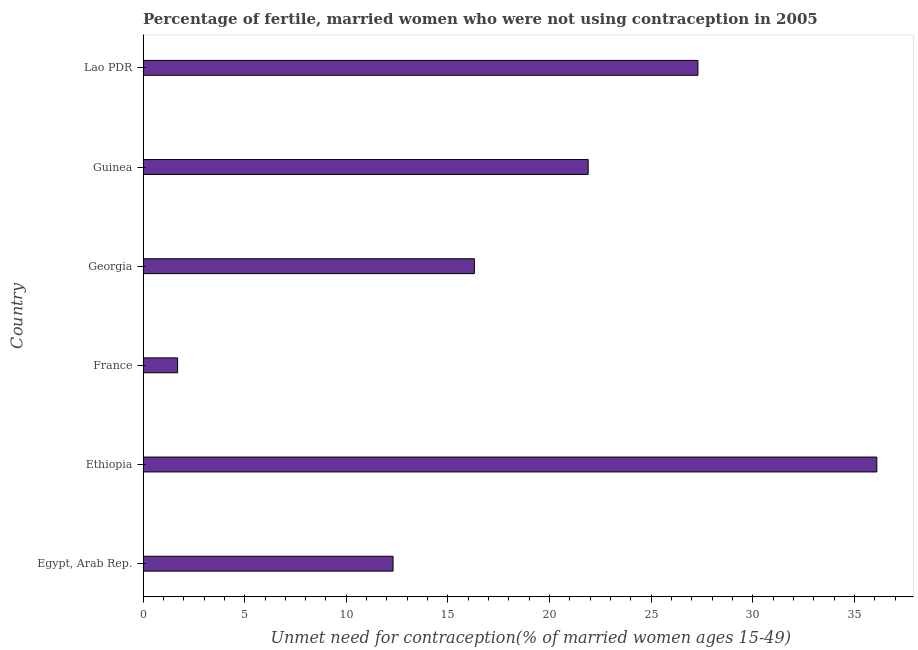Does the graph contain grids?
Your response must be concise. No. What is the title of the graph?
Keep it short and to the point. Percentage of fertile, married women who were not using contraception in 2005. What is the label or title of the X-axis?
Offer a terse response.  Unmet need for contraception(% of married women ages 15-49). Across all countries, what is the maximum number of married women who are not using contraception?
Provide a succinct answer. 36.1. Across all countries, what is the minimum number of married women who are not using contraception?
Offer a very short reply. 1.7. In which country was the number of married women who are not using contraception maximum?
Your response must be concise. Ethiopia. What is the sum of the number of married women who are not using contraception?
Keep it short and to the point. 115.6. What is the difference between the number of married women who are not using contraception in France and Lao PDR?
Keep it short and to the point. -25.6. What is the average number of married women who are not using contraception per country?
Keep it short and to the point. 19.27. What is the median number of married women who are not using contraception?
Your answer should be very brief. 19.1. What is the ratio of the number of married women who are not using contraception in Egypt, Arab Rep. to that in France?
Offer a very short reply. 7.24. What is the difference between the highest and the second highest number of married women who are not using contraception?
Ensure brevity in your answer.  8.8. What is the difference between the highest and the lowest number of married women who are not using contraception?
Offer a terse response. 34.4. How many bars are there?
Ensure brevity in your answer.  6. Are all the bars in the graph horizontal?
Offer a terse response. Yes. How many countries are there in the graph?
Your answer should be compact. 6. What is the  Unmet need for contraception(% of married women ages 15-49) in Egypt, Arab Rep.?
Your response must be concise. 12.3. What is the  Unmet need for contraception(% of married women ages 15-49) in Ethiopia?
Give a very brief answer. 36.1. What is the  Unmet need for contraception(% of married women ages 15-49) of Guinea?
Ensure brevity in your answer.  21.9. What is the  Unmet need for contraception(% of married women ages 15-49) in Lao PDR?
Your answer should be compact. 27.3. What is the difference between the  Unmet need for contraception(% of married women ages 15-49) in Egypt, Arab Rep. and Ethiopia?
Offer a terse response. -23.8. What is the difference between the  Unmet need for contraception(% of married women ages 15-49) in Egypt, Arab Rep. and Guinea?
Provide a succinct answer. -9.6. What is the difference between the  Unmet need for contraception(% of married women ages 15-49) in Egypt, Arab Rep. and Lao PDR?
Provide a succinct answer. -15. What is the difference between the  Unmet need for contraception(% of married women ages 15-49) in Ethiopia and France?
Your answer should be compact. 34.4. What is the difference between the  Unmet need for contraception(% of married women ages 15-49) in Ethiopia and Georgia?
Your answer should be very brief. 19.8. What is the difference between the  Unmet need for contraception(% of married women ages 15-49) in Ethiopia and Lao PDR?
Offer a terse response. 8.8. What is the difference between the  Unmet need for contraception(% of married women ages 15-49) in France and Georgia?
Keep it short and to the point. -14.6. What is the difference between the  Unmet need for contraception(% of married women ages 15-49) in France and Guinea?
Provide a succinct answer. -20.2. What is the difference between the  Unmet need for contraception(% of married women ages 15-49) in France and Lao PDR?
Your answer should be very brief. -25.6. What is the difference between the  Unmet need for contraception(% of married women ages 15-49) in Georgia and Guinea?
Offer a very short reply. -5.6. What is the difference between the  Unmet need for contraception(% of married women ages 15-49) in Georgia and Lao PDR?
Your answer should be very brief. -11. What is the ratio of the  Unmet need for contraception(% of married women ages 15-49) in Egypt, Arab Rep. to that in Ethiopia?
Give a very brief answer. 0.34. What is the ratio of the  Unmet need for contraception(% of married women ages 15-49) in Egypt, Arab Rep. to that in France?
Make the answer very short. 7.24. What is the ratio of the  Unmet need for contraception(% of married women ages 15-49) in Egypt, Arab Rep. to that in Georgia?
Keep it short and to the point. 0.76. What is the ratio of the  Unmet need for contraception(% of married women ages 15-49) in Egypt, Arab Rep. to that in Guinea?
Your answer should be compact. 0.56. What is the ratio of the  Unmet need for contraception(% of married women ages 15-49) in Egypt, Arab Rep. to that in Lao PDR?
Provide a succinct answer. 0.45. What is the ratio of the  Unmet need for contraception(% of married women ages 15-49) in Ethiopia to that in France?
Keep it short and to the point. 21.23. What is the ratio of the  Unmet need for contraception(% of married women ages 15-49) in Ethiopia to that in Georgia?
Your answer should be very brief. 2.21. What is the ratio of the  Unmet need for contraception(% of married women ages 15-49) in Ethiopia to that in Guinea?
Keep it short and to the point. 1.65. What is the ratio of the  Unmet need for contraception(% of married women ages 15-49) in Ethiopia to that in Lao PDR?
Your answer should be compact. 1.32. What is the ratio of the  Unmet need for contraception(% of married women ages 15-49) in France to that in Georgia?
Make the answer very short. 0.1. What is the ratio of the  Unmet need for contraception(% of married women ages 15-49) in France to that in Guinea?
Make the answer very short. 0.08. What is the ratio of the  Unmet need for contraception(% of married women ages 15-49) in France to that in Lao PDR?
Your answer should be compact. 0.06. What is the ratio of the  Unmet need for contraception(% of married women ages 15-49) in Georgia to that in Guinea?
Provide a short and direct response. 0.74. What is the ratio of the  Unmet need for contraception(% of married women ages 15-49) in Georgia to that in Lao PDR?
Provide a succinct answer. 0.6. What is the ratio of the  Unmet need for contraception(% of married women ages 15-49) in Guinea to that in Lao PDR?
Offer a terse response. 0.8. 